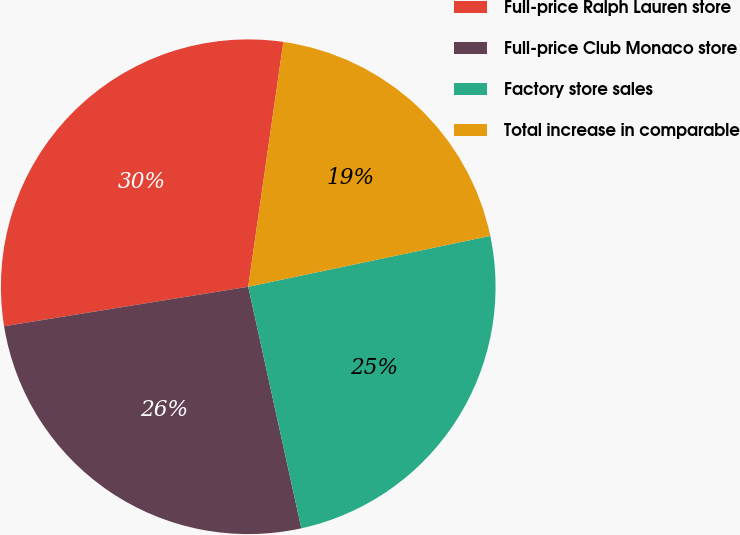Convert chart. <chart><loc_0><loc_0><loc_500><loc_500><pie_chart><fcel>Full-price Ralph Lauren store<fcel>Full-price Club Monaco store<fcel>Factory store sales<fcel>Total increase in comparable<nl><fcel>29.82%<fcel>25.89%<fcel>24.85%<fcel>19.43%<nl></chart> 